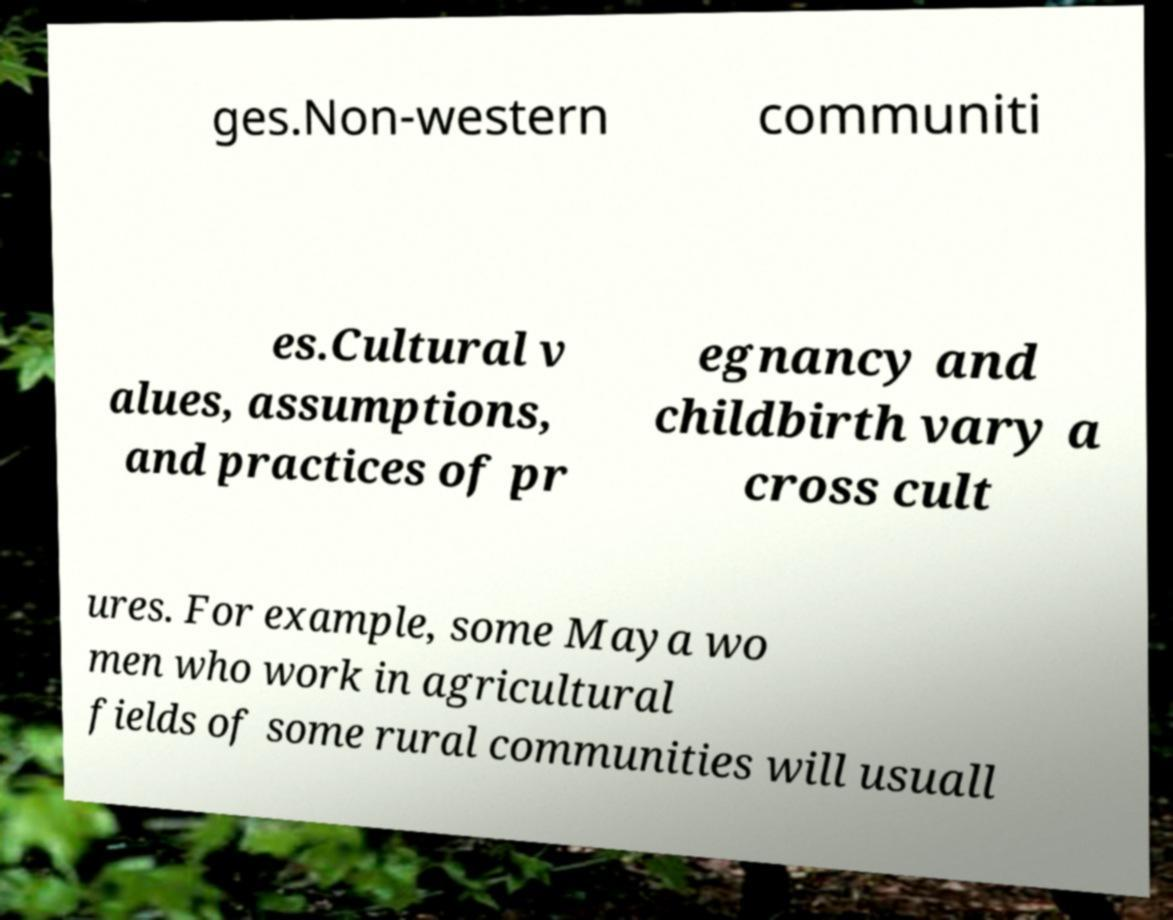Could you assist in decoding the text presented in this image and type it out clearly? ges.Non-western communiti es.Cultural v alues, assumptions, and practices of pr egnancy and childbirth vary a cross cult ures. For example, some Maya wo men who work in agricultural fields of some rural communities will usuall 